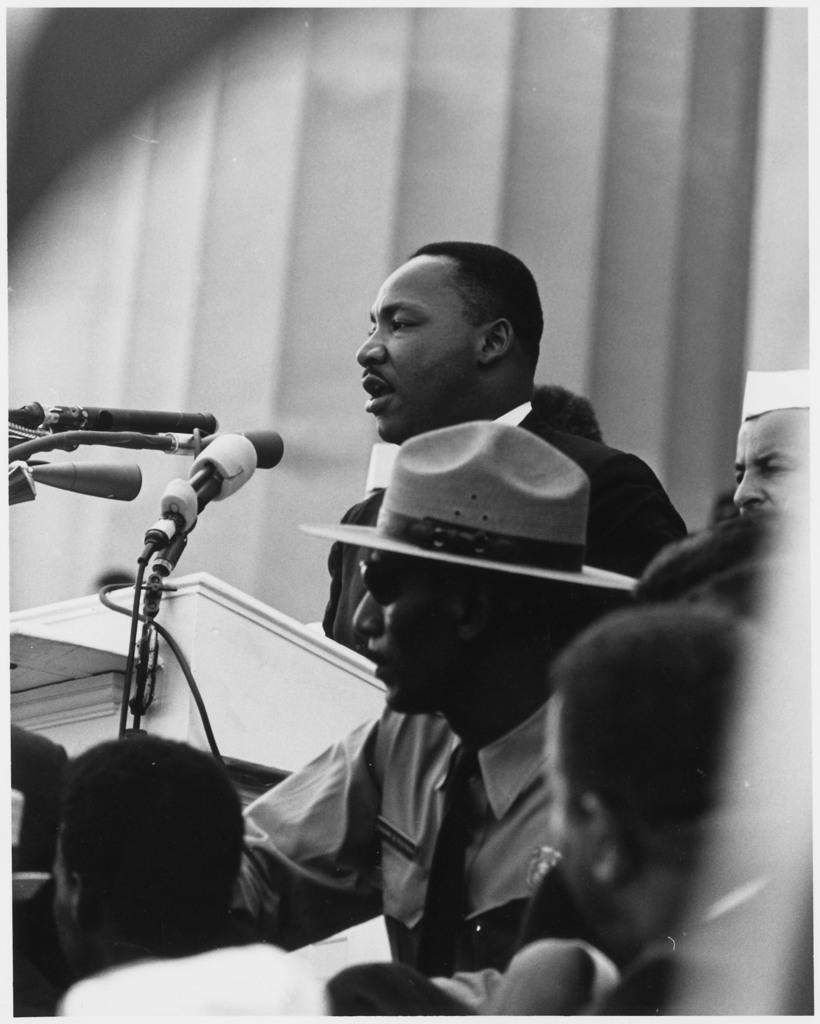Please provide a concise description of this image. This is a black and white picture. Here we can see people, mikes, and a podium. In the background there is a wall. 